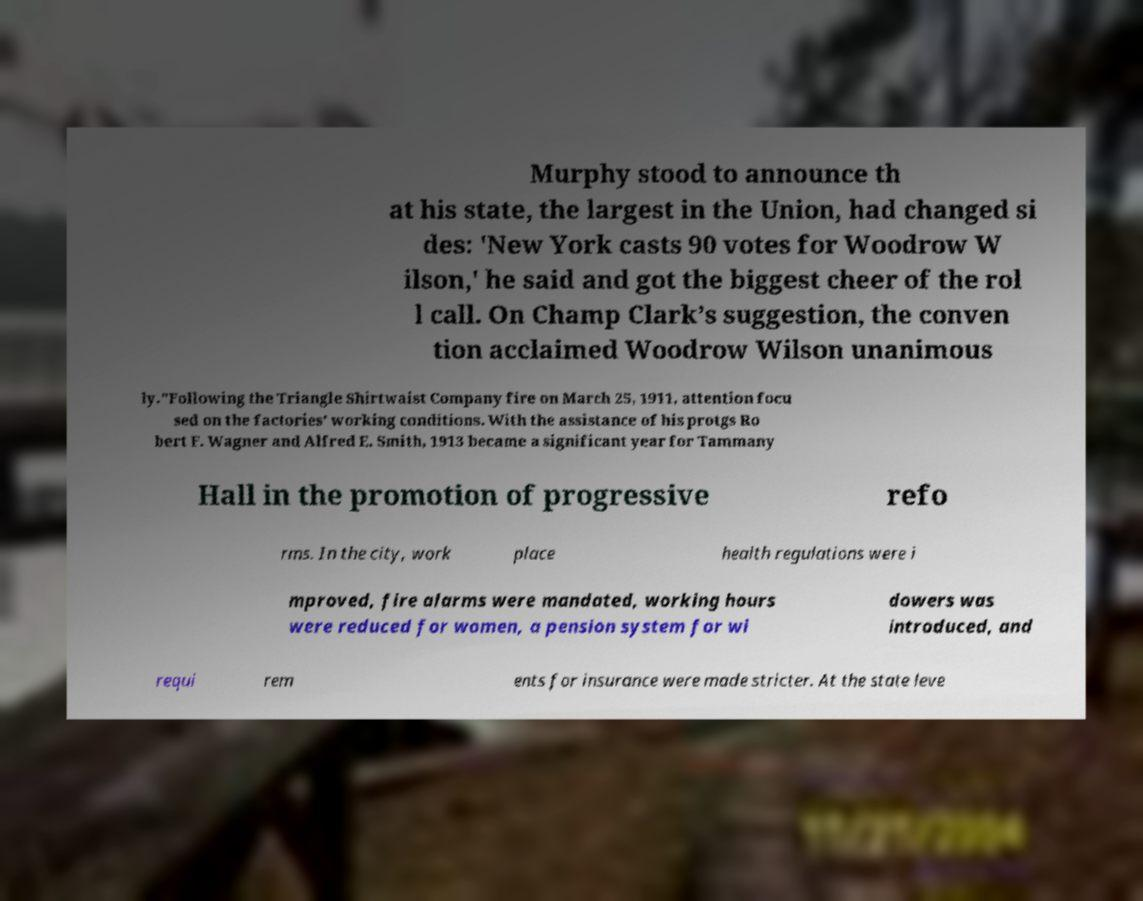For documentation purposes, I need the text within this image transcribed. Could you provide that? Murphy stood to announce th at his state, the largest in the Union, had changed si des: 'New York casts 90 votes for Woodrow W ilson,' he said and got the biggest cheer of the rol l call. On Champ Clark’s suggestion, the conven tion acclaimed Woodrow Wilson unanimous ly."Following the Triangle Shirtwaist Company fire on March 25, 1911, attention focu sed on the factories' working conditions. With the assistance of his protgs Ro bert F. Wagner and Alfred E. Smith, 1913 became a significant year for Tammany Hall in the promotion of progressive refo rms. In the city, work place health regulations were i mproved, fire alarms were mandated, working hours were reduced for women, a pension system for wi dowers was introduced, and requi rem ents for insurance were made stricter. At the state leve 